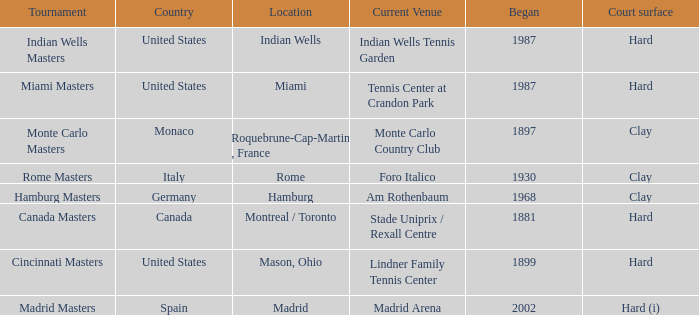Which contests are currently held at the madrid arena? Madrid Masters. 